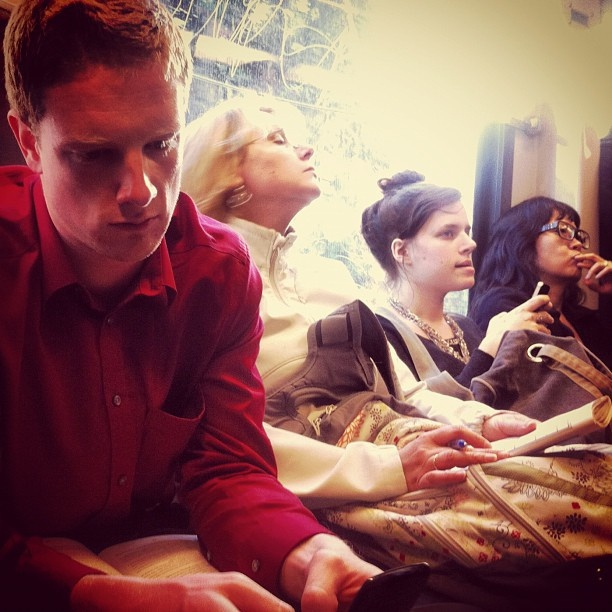Describe the objects in this image and their specific colors. I can see people in brown, maroon, and black tones, people in brown, beige, and tan tones, people in brown, lightpink, lightgray, and purple tones, handbag in brown, maroon, and black tones, and people in brown, purple, black, and maroon tones in this image. 